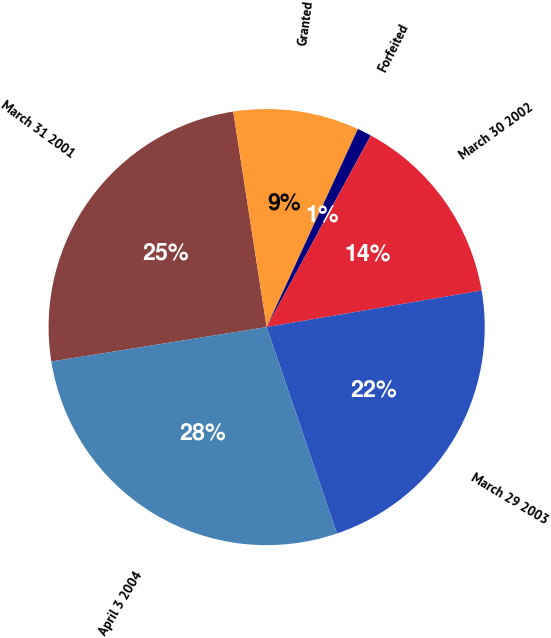Convert chart. <chart><loc_0><loc_0><loc_500><loc_500><pie_chart><fcel>March 31 2001<fcel>Granted<fcel>Forfeited<fcel>March 30 2002<fcel>March 29 2003<fcel>April 3 2004<nl><fcel>25.08%<fcel>9.32%<fcel>1.05%<fcel>14.4%<fcel>22.46%<fcel>27.7%<nl></chart> 